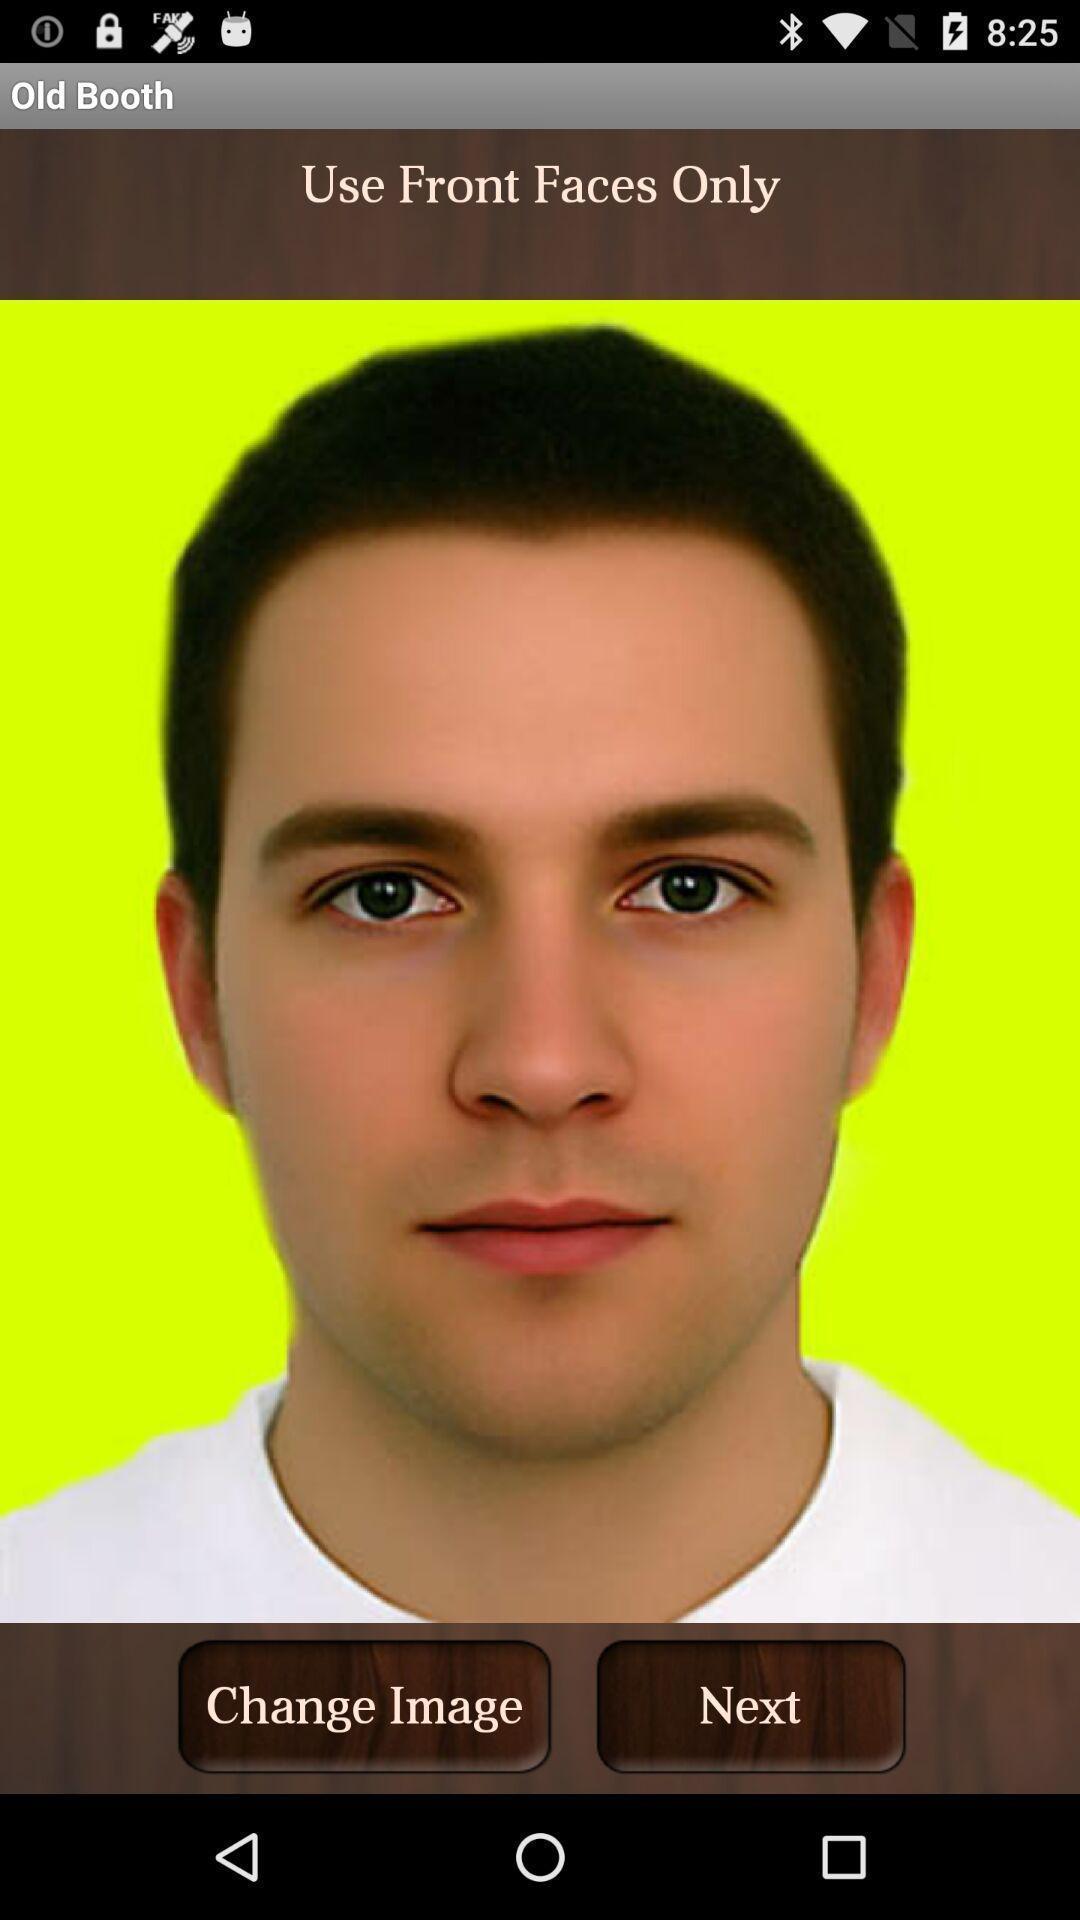Summarize the main components in this picture. Use front faces only in change image. 